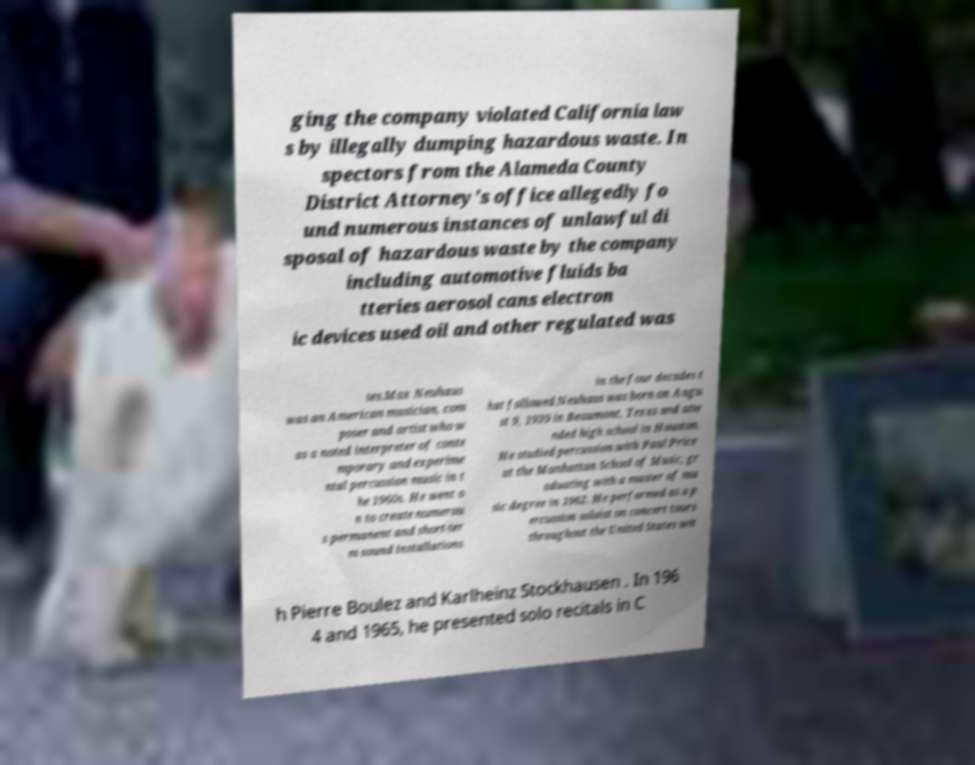Could you assist in decoding the text presented in this image and type it out clearly? ging the company violated California law s by illegally dumping hazardous waste. In spectors from the Alameda County District Attorney's office allegedly fo und numerous instances of unlawful di sposal of hazardous waste by the company including automotive fluids ba tteries aerosol cans electron ic devices used oil and other regulated was tes.Max Neuhaus was an American musician, com poser and artist who w as a noted interpreter of conte mporary and experime ntal percussion music in t he 1960s. He went o n to create numerou s permanent and short-ter m sound installations in the four decades t hat followed.Neuhaus was born on Augu st 9, 1939 in Beaumont, Texas and atte nded high school in Houston. He studied percussion with Paul Price at the Manhattan School of Music, gr aduating with a master of mu sic degree in 1962. He performed as a p ercussion soloist on concert tours throughout the United States wit h Pierre Boulez and Karlheinz Stockhausen . In 196 4 and 1965, he presented solo recitals in C 